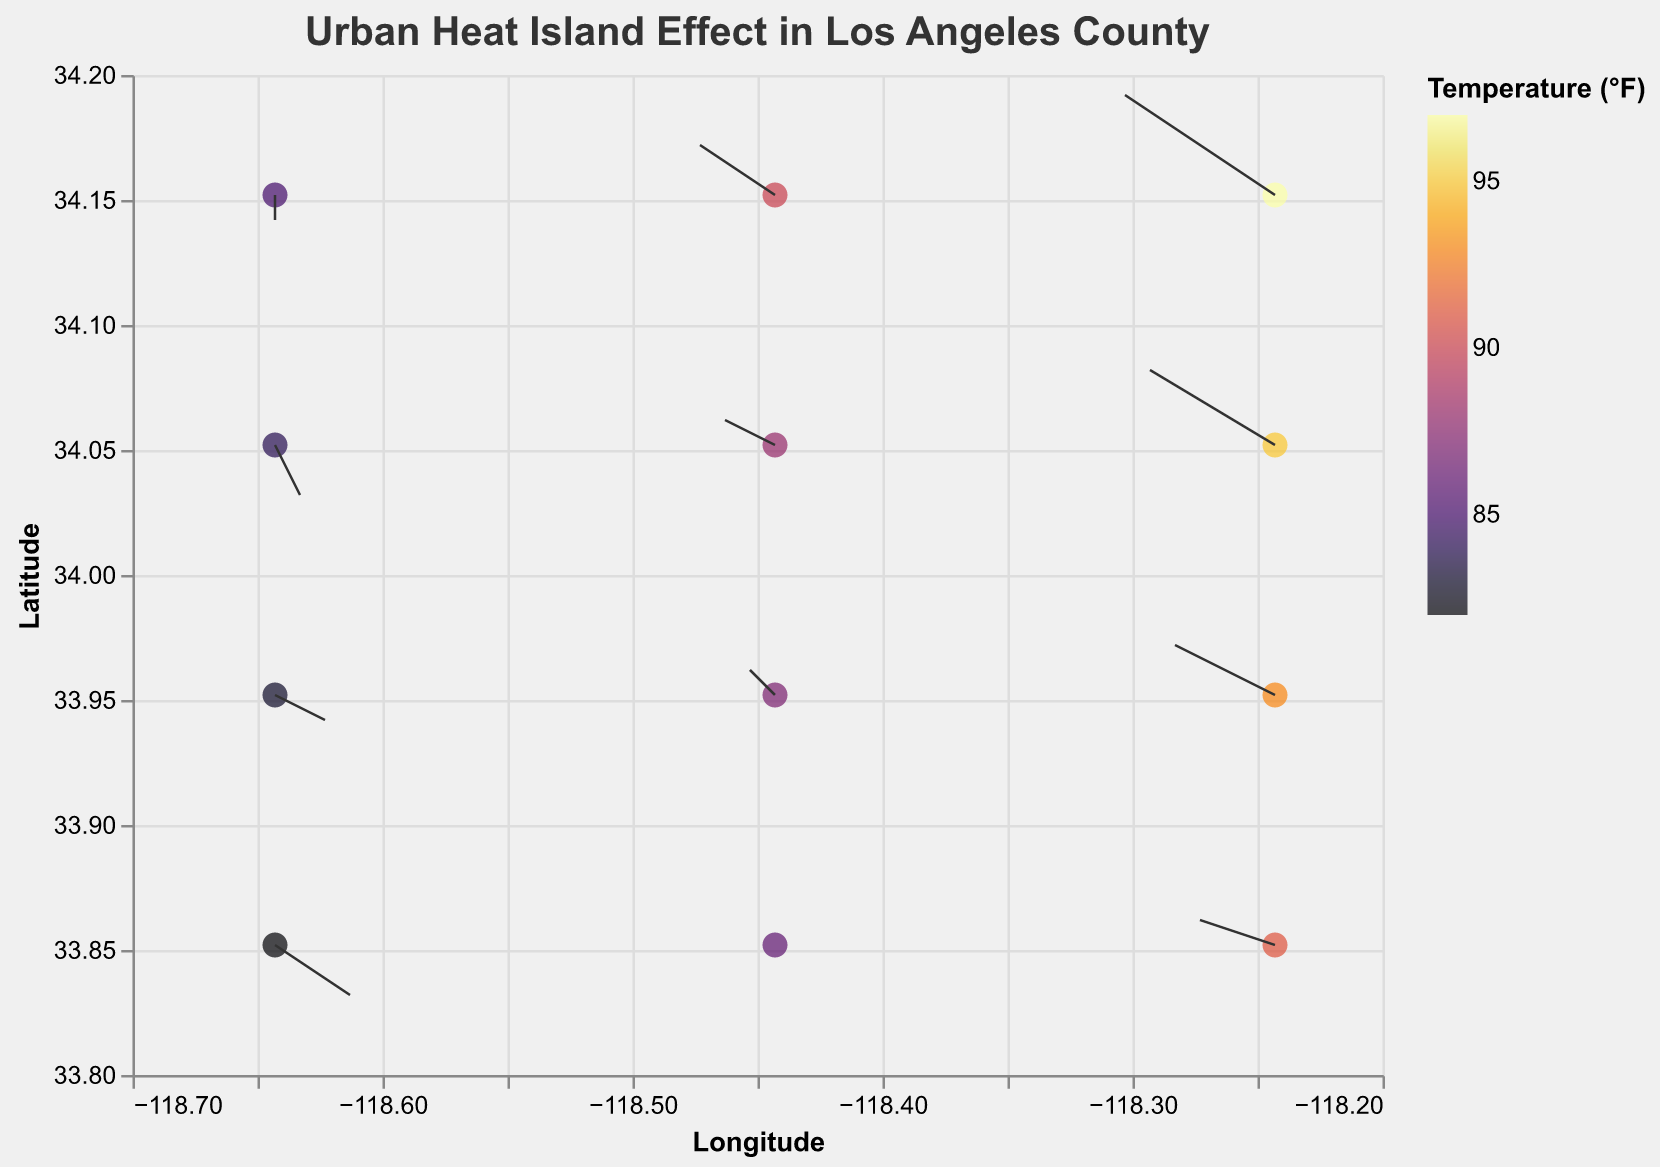What's the title of the figure? The title of the figure is displayed at the top center. The given title is clear and easy to read.
Answer: Urban Heat Island Effect in Los Angeles County What does the color scale represent? The color scale on the right-hand side of the figure shows the temperature in degrees Fahrenheit. The colors range from yellow for lower temperatures to dark purple for higher temperatures.
Answer: Temperature (°F) What are the axes representing? The x-axis represents Longitude, spanning values from -118.7 to -118.2, while the y-axis represents Latitude, spanning values from 33.8 to 34.2. This helps locate the points geographically.
Answer: Longitude and Latitude How many data points are plotted on the figure? By examining the number of points on the plot, you can count a total of 12 data points indicated by the number of unique locations plotted.
Answer: 12 Which location has the highest temperature, and what is the temperature? The location with the highest temperature is identified by the darkest color and highest value on the color legend. The coordinates 34.152, -118.243 correspond to the highest temperature, 97°F.
Answer: 34.152, -118.243, 97°F Which location has the lowest temperature, and what is the temperature? The location with the lowest temperature is identified by the lightest color and lowest value on the color legend. The coordinates 33.852, -118.643 correspond to the lowest temperature, 82°F.
Answer: 33.852, -118.643, 82°F What is the average temperature of the plotted data points? Sum the temperatures of all 12 data points and divide by the number of points. (95 + 88 + 84 + 93 + 87 + 83 + 91 + 86 + 82 + 97 + 90 + 85) / 12.
Answer: 88.25°F What is the direction and magnitude of the vector at (34.052, -118.243)? The vector at (34.052, -118.243) has a direction of (-0.5, 0.3). To find the magnitude, use the formula √(u² + v²) ≈ √((-0.5)² + (0.3)²) = √(0.34) ≈ 0.58.
Answer: Magnitude: 0.58 Compare the intensity and direction of vectors at (34.052, -118.443) and (34.052, -118.643). The vector at (34.052, -118.443) has a direction of (-0.2, 0.1), whereas the vector at (34.052, -118.643) has a direction of (0.1, -0.2). The magnitude of vectors are √(0.05) ≈ 0.22 and √(0.05) ≈ 0.22 respectively. They have similar intensities but opposite directions.
Answer: Similar intensities, opposite directions Which data point shows no vector displacement? A zero vector indicates no displacement. The point at (33.852, -118.443) has a vector (0, 0).
Answer: 33.852, -118.443 